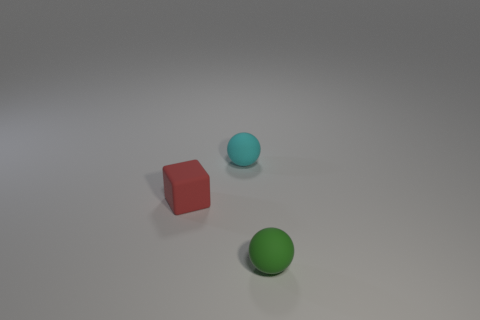Is the material of the tiny sphere behind the green matte thing the same as the cube?
Provide a succinct answer. Yes. There is a small thing behind the small object on the left side of the small rubber object behind the tiny block; what is its shape?
Ensure brevity in your answer.  Sphere. Are there any red matte objects of the same size as the red block?
Offer a very short reply. No. The red matte thing has what size?
Offer a terse response. Small. How many rubber balls have the same size as the red thing?
Provide a short and direct response. 2. Is the number of small green rubber objects that are left of the cyan object less than the number of red things that are on the left side of the small rubber block?
Provide a succinct answer. No. What is the size of the matte ball behind the matte ball that is right of the small matte object behind the tiny matte cube?
Your answer should be compact. Small. There is a object that is both behind the small green ball and on the right side of the tiny red rubber block; how big is it?
Your answer should be compact. Small. The tiny rubber thing that is to the left of the ball behind the rubber block is what shape?
Ensure brevity in your answer.  Cube. Is there any other thing of the same color as the rubber block?
Offer a very short reply. No. 